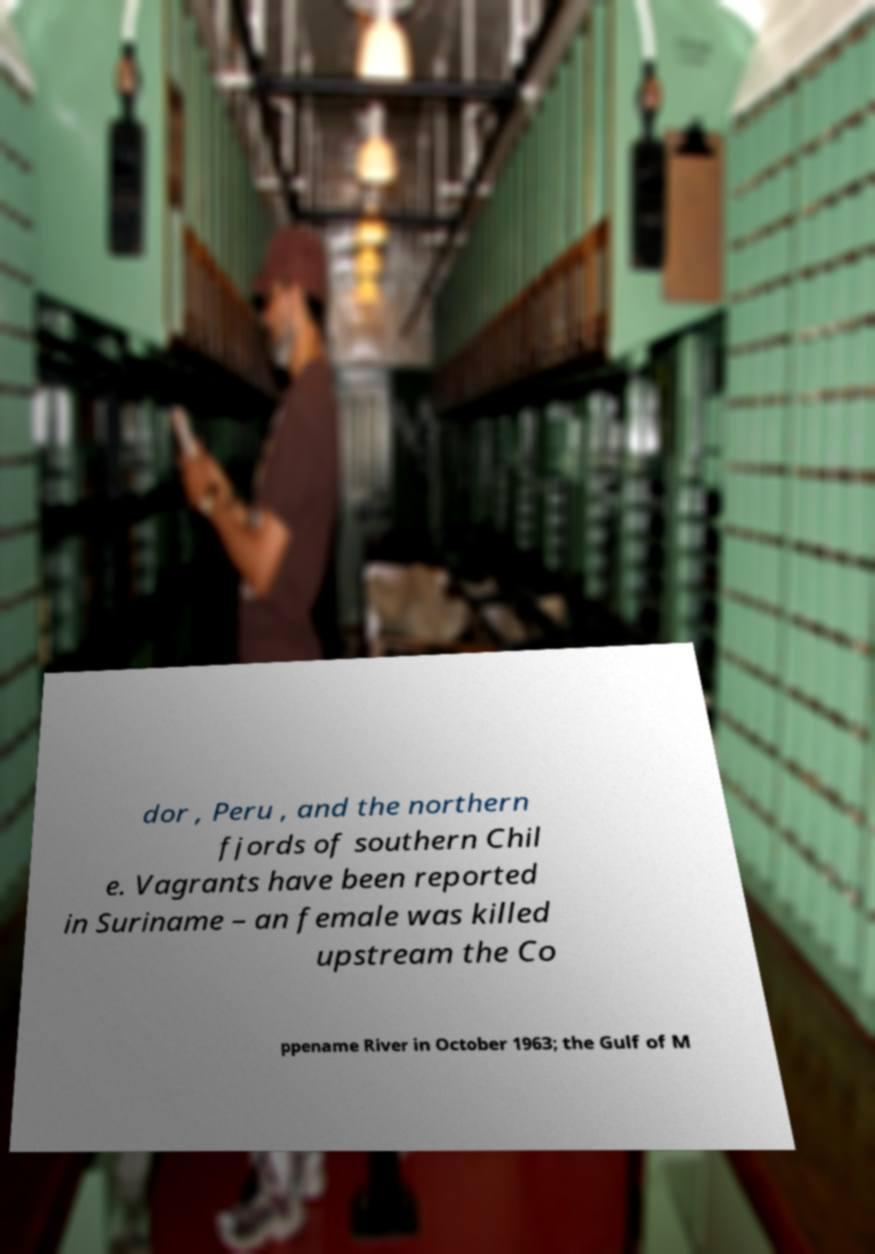I need the written content from this picture converted into text. Can you do that? dor , Peru , and the northern fjords of southern Chil e. Vagrants have been reported in Suriname – an female was killed upstream the Co ppename River in October 1963; the Gulf of M 